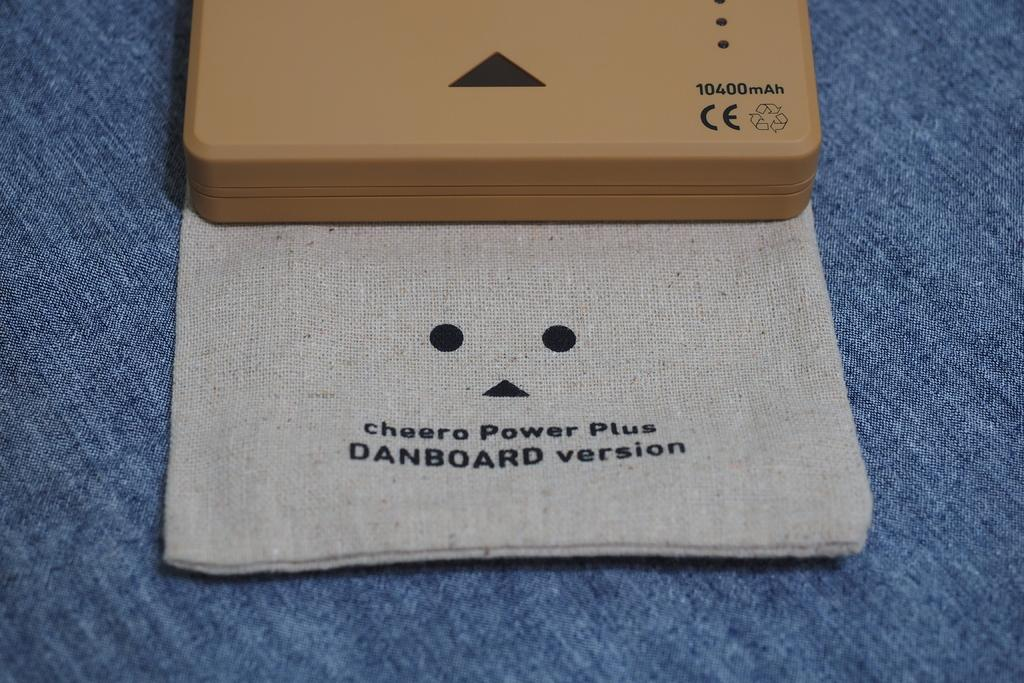<image>
Give a short and clear explanation of the subsequent image. A case and sleeve for the cheero Power Plus Danboard version. 